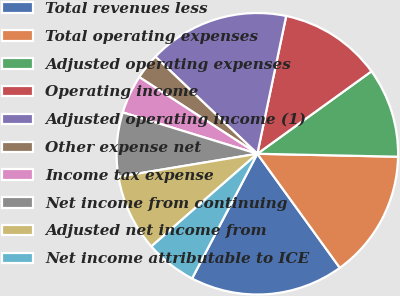<chart> <loc_0><loc_0><loc_500><loc_500><pie_chart><fcel>Total revenues less<fcel>Total operating expenses<fcel>Adjusted operating expenses<fcel>Operating income<fcel>Adjusted operating income (1)<fcel>Other expense net<fcel>Income tax expense<fcel>Net income from continuing<fcel>Adjusted net income from<fcel>Net income attributable to ICE<nl><fcel>17.64%<fcel>14.7%<fcel>10.29%<fcel>11.76%<fcel>16.17%<fcel>2.95%<fcel>4.42%<fcel>7.36%<fcel>8.82%<fcel>5.89%<nl></chart> 